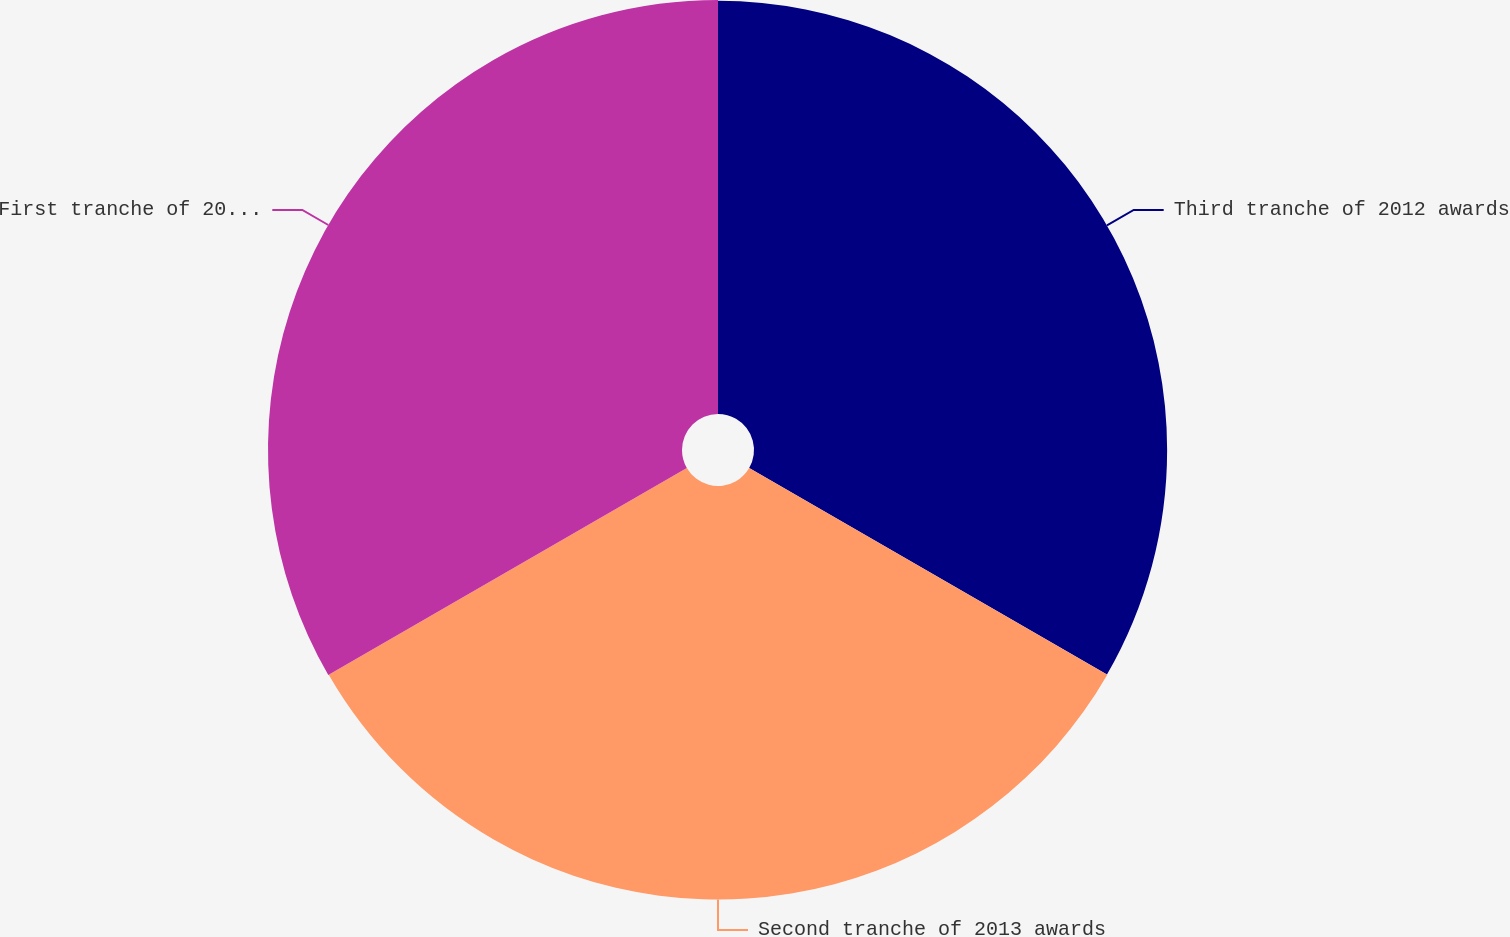<chart> <loc_0><loc_0><loc_500><loc_500><pie_chart><fcel>Third tranche of 2012 awards<fcel>Second tranche of 2013 awards<fcel>First tranche of 2014 awards<nl><fcel>33.3%<fcel>33.33%<fcel>33.37%<nl></chart> 